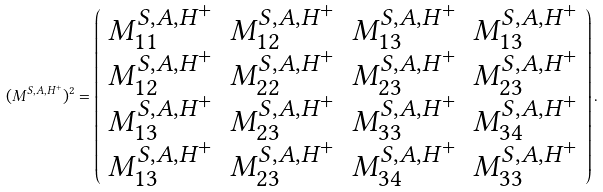Convert formula to latex. <formula><loc_0><loc_0><loc_500><loc_500>( M ^ { S , A , H ^ { + } } ) ^ { 2 } = \left ( \begin{array} { c c c c } M ^ { S , A , H ^ { + } } _ { 1 1 } & M ^ { S , A , H ^ { + } } _ { 1 2 } & M ^ { S , A , H ^ { + } } _ { 1 3 } & M ^ { S , A , H ^ { + } } _ { 1 3 } \\ M ^ { S , A , H ^ { + } } _ { 1 2 } & M ^ { S , A , H ^ { + } } _ { 2 2 } & M ^ { S , A , H ^ { + } } _ { 2 3 } & M ^ { S , A , H ^ { + } } _ { 2 3 } \\ M ^ { S , A , H ^ { + } } _ { 1 3 } & M ^ { S , A , H ^ { + } } _ { 2 3 } & M ^ { S , A , H ^ { + } } _ { 3 3 } & M ^ { S , A , H ^ { + } } _ { 3 4 } \\ M ^ { S , A , H ^ { + } } _ { 1 3 } & M ^ { S , A , H ^ { + } } _ { 2 3 } & M ^ { S , A , H ^ { + } } _ { 3 4 } & M ^ { S , A , H ^ { + } } _ { 3 3 } \end{array} \right ) .</formula> 